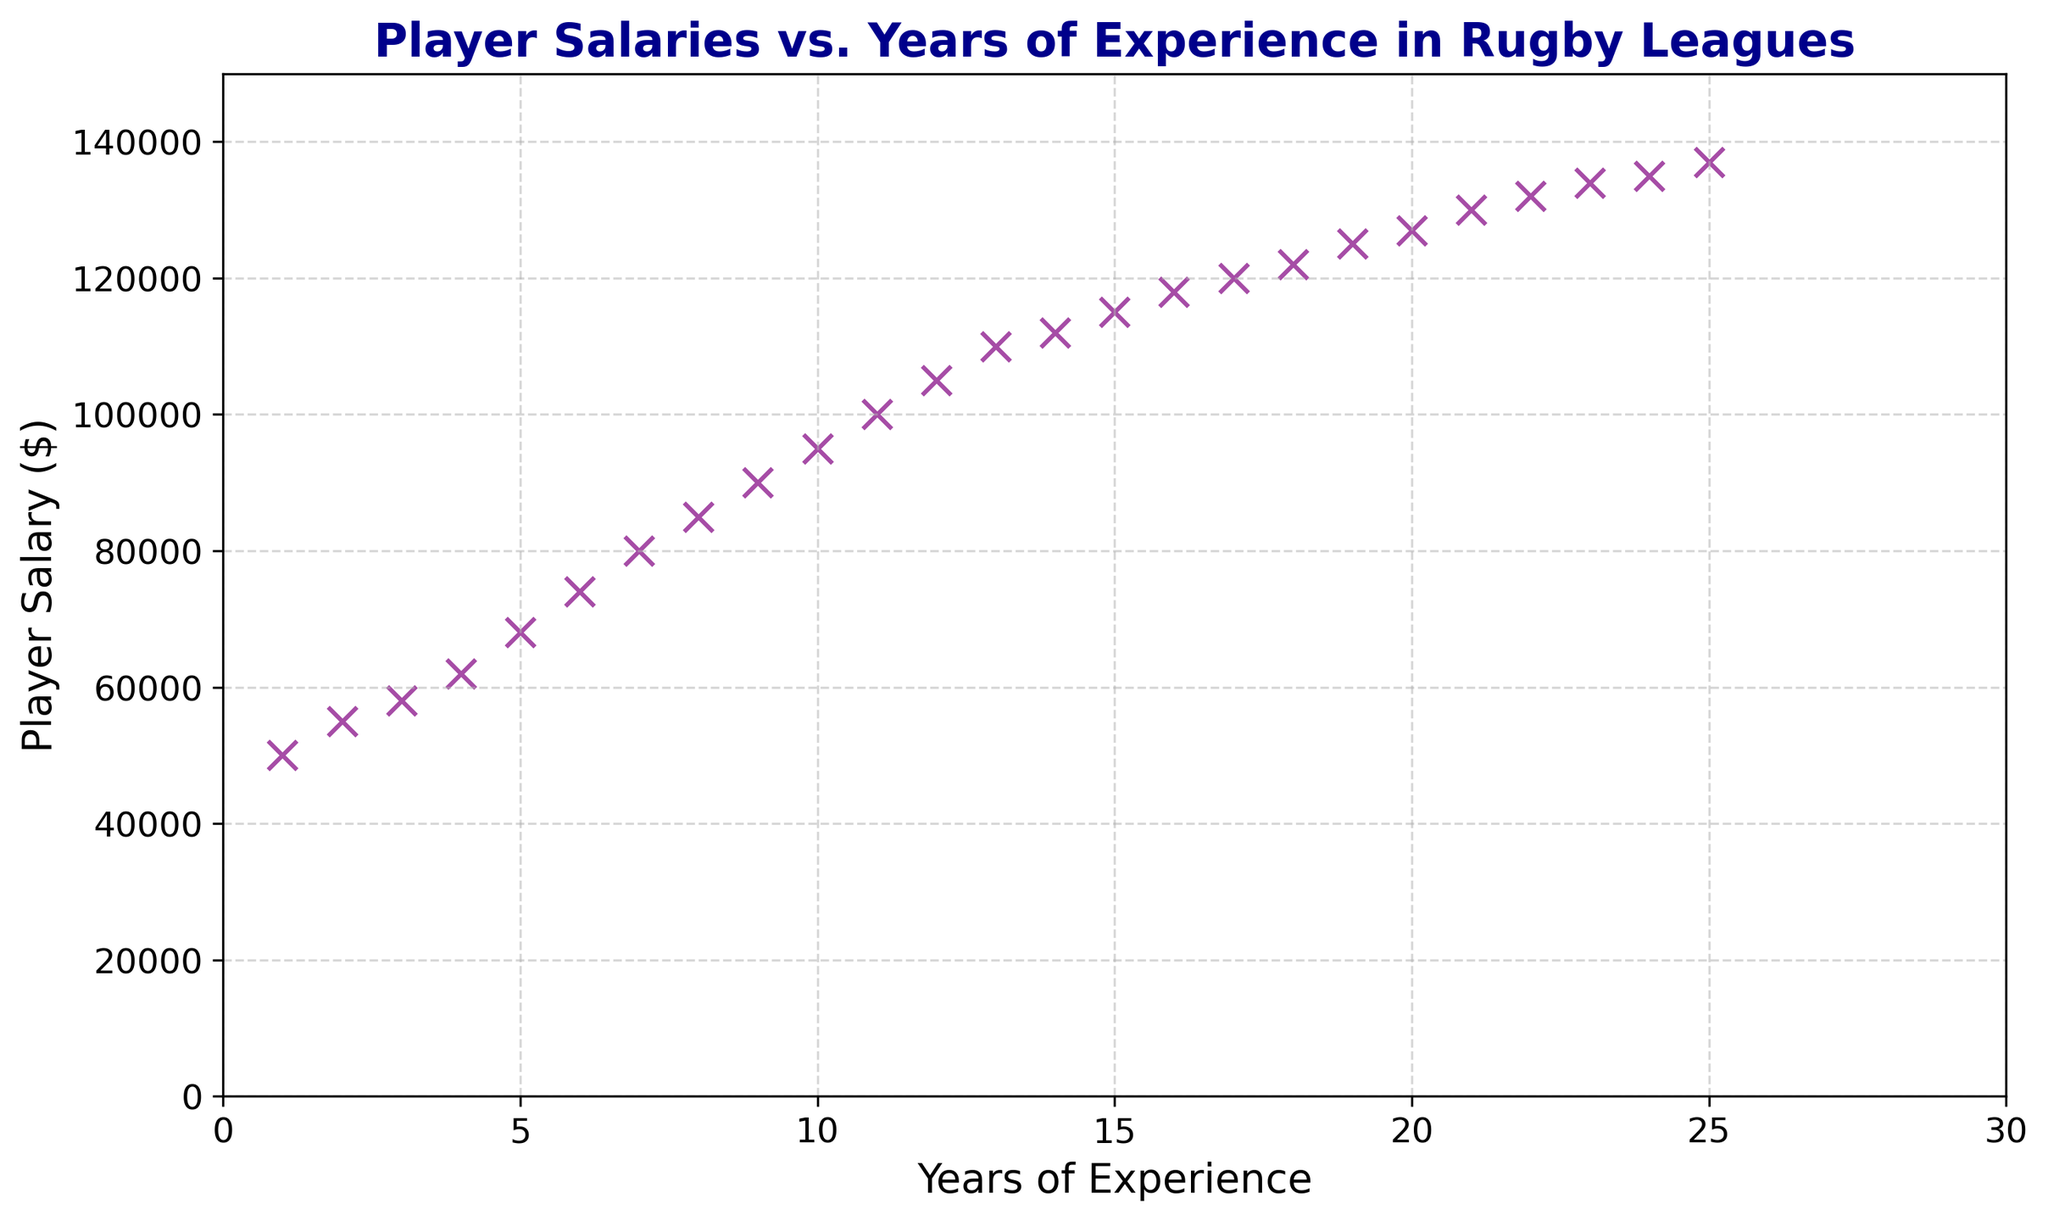How many players have more than 15 years of experience? To determine the number of players with more than 15 years of experience, count the data points on the scatter plot that are positioned to the right of the 15-year mark on the x-axis.
Answer: 10 What is the salary range for players with less than 5 years of experience? To find the salary range for players with less than 5 years of experience, locate the data points for 1 to 4 years of experience on the x-axis and note their corresponding y-axis values (salaries). The range would be the difference between the maximum and minimum salaries among these points.
Answer: 50000 to 62000 What’s the average salary for players with exactly 10 years of experience? Look at the data point corresponding to 10 years of experience on the x-axis and note its y-axis value, which is the salary. Since there's only one data point at 10 years of experience, that's the average salary.
Answer: 95000 Which player has a higher salary: someone with 8 years of experience or someone with 12 years of experience? Compare the y-axis values (salaries) of the data points at 8 years of experience and 12 years of experience on the x-axis. Note the higher value.
Answer: 12 years of experience What's the trend of player salaries with increasing years of experience? Observe the overall direction of the scatter plot points as you move from left (less experience) to right (more experience). The points generally rise, indicating an increase in salaries with more years of experience.
Answer: Increases What’s the difference in salary between players with 6 years of experience and 16 years of experience? Find the y-axis values for the data points at 6 years and 16 years of experience (74000 and 118000 respectively). Subtract the smaller value from the larger one to find the difference.
Answer: 44000 Do any players have a salary over 120,000? Check the y-axis values of all data points to see if any point is positioned above the 120,000 mark.
Answer: Yes How much more does a player with 20 years of experience earn compared to one with 10 years of experience? Locate the y-axis values for the data points at 20 years of experience (127000) and 10 years of experience (95000). Subtract the salary at 10 years from the salary at 20 years.
Answer: 32000 What is the median salary for players with 5 to 15 years of experience? Identify the y-axis values (salaries) of data points from 5 to 15 years of experience. Arrange these salaries in numerical order and find the middle value. If there's an even number of values, average the two middle values.
Answer: 105000 